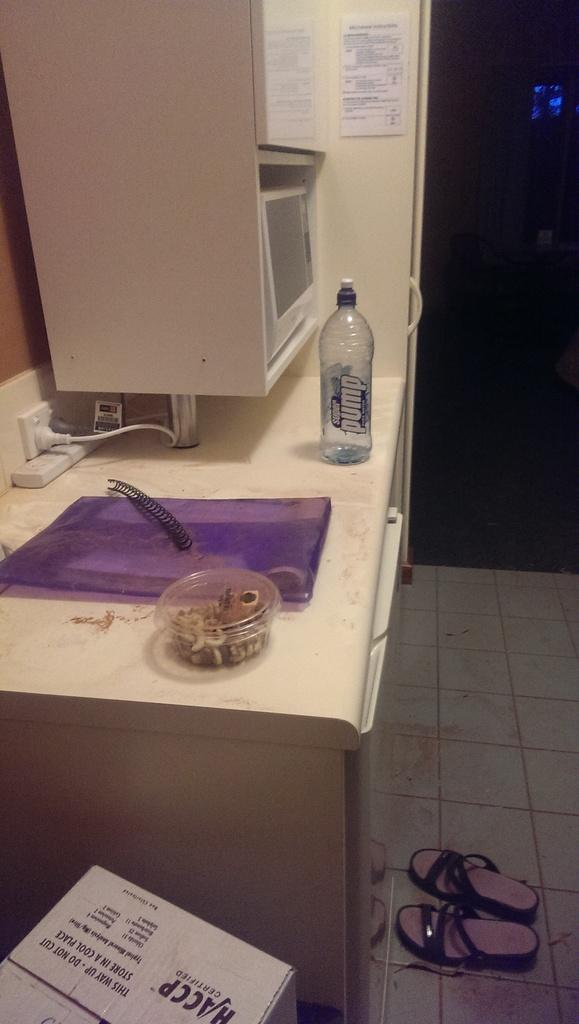<image>
Create a compact narrative representing the image presented. A Super Pump bottle stands on a counter in a lab. 